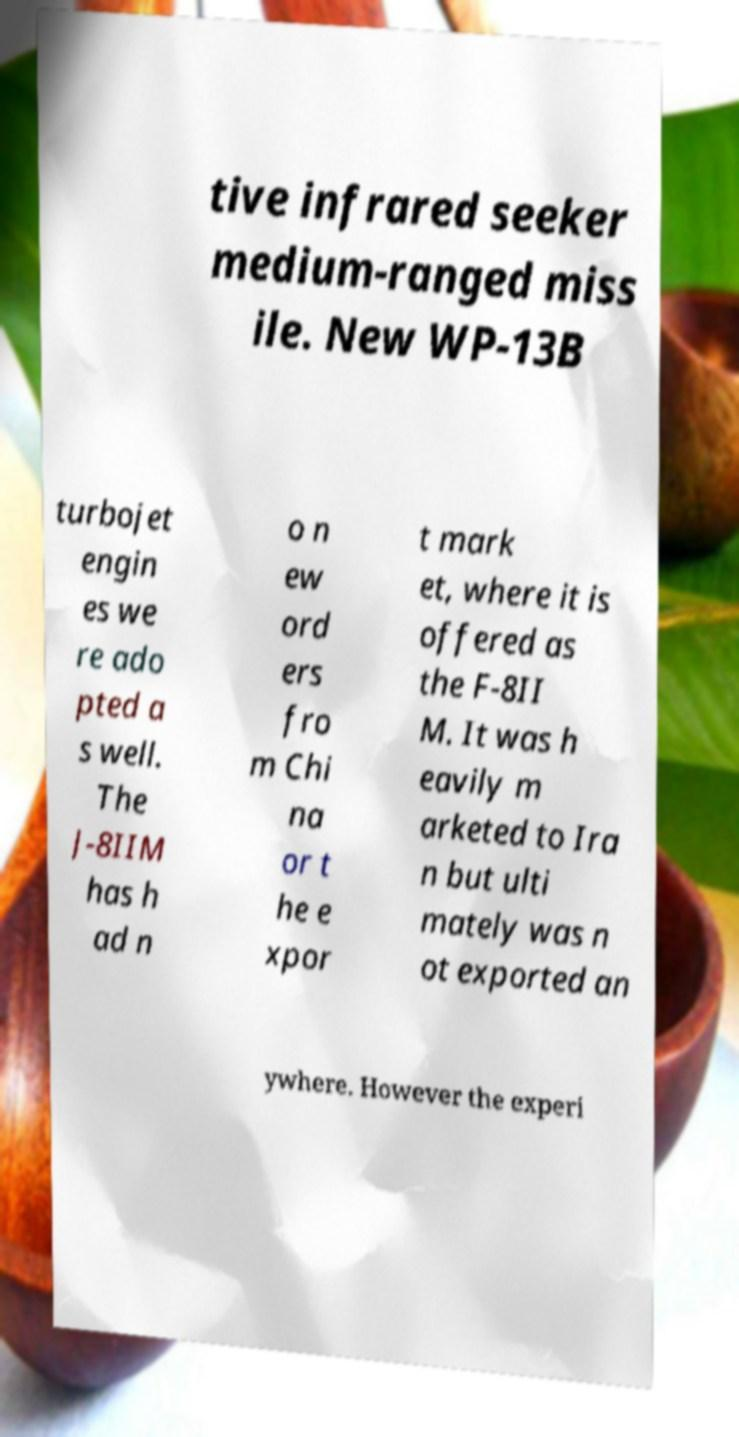Can you accurately transcribe the text from the provided image for me? tive infrared seeker medium-ranged miss ile. New WP-13B turbojet engin es we re ado pted a s well. The J-8IIM has h ad n o n ew ord ers fro m Chi na or t he e xpor t mark et, where it is offered as the F-8II M. It was h eavily m arketed to Ira n but ulti mately was n ot exported an ywhere. However the experi 